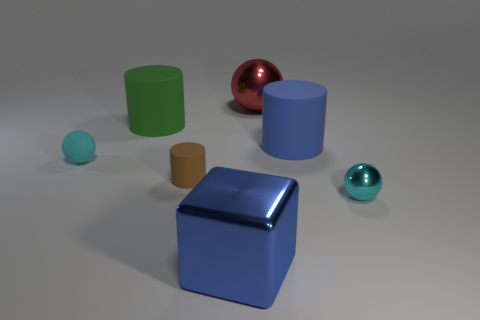Add 1 small shiny cylinders. How many objects exist? 8 Subtract all blocks. How many objects are left? 6 Subtract all tiny blue cylinders. Subtract all tiny brown cylinders. How many objects are left? 6 Add 3 blue matte things. How many blue matte things are left? 4 Add 1 large gray rubber objects. How many large gray rubber objects exist? 1 Subtract 1 red balls. How many objects are left? 6 